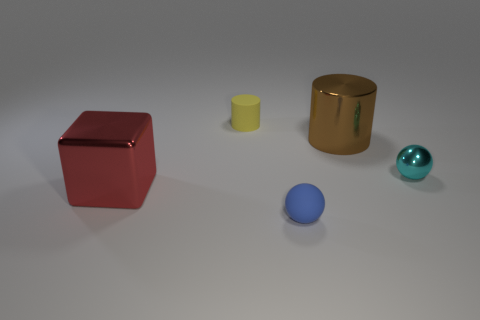Add 1 tiny cyan things. How many objects exist? 6 Subtract all cylinders. How many objects are left? 3 Subtract all large blue cubes. Subtract all small cylinders. How many objects are left? 4 Add 4 big metal blocks. How many big metal blocks are left? 5 Add 3 large purple shiny things. How many large purple shiny things exist? 3 Subtract 0 gray cubes. How many objects are left? 5 